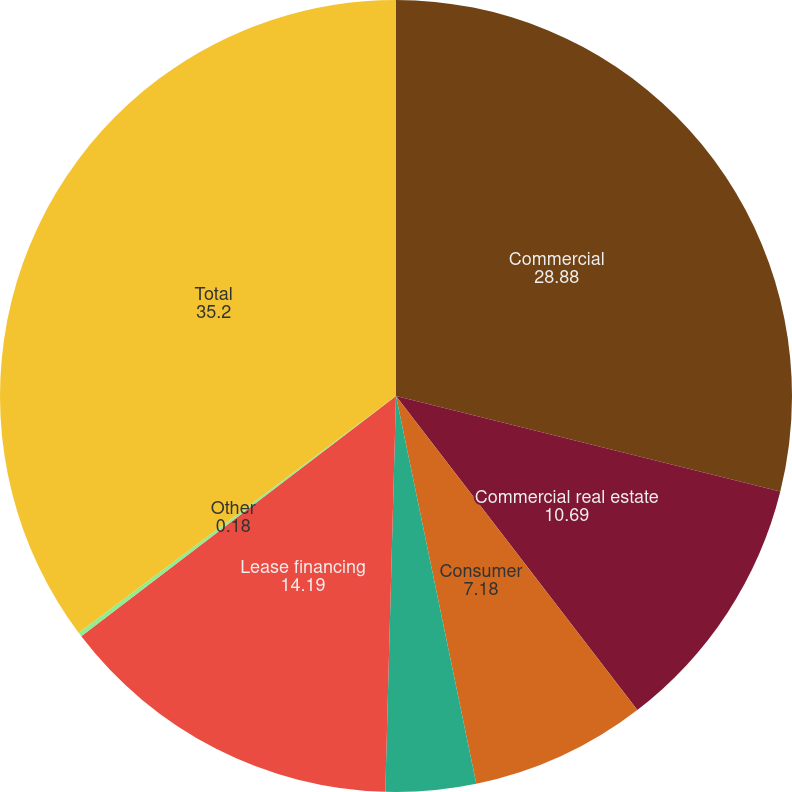Convert chart to OTSL. <chart><loc_0><loc_0><loc_500><loc_500><pie_chart><fcel>Commercial<fcel>Commercial real estate<fcel>Consumer<fcel>Residential mortgage<fcel>Lease financing<fcel>Other<fcel>Total<nl><fcel>28.88%<fcel>10.69%<fcel>7.18%<fcel>3.68%<fcel>14.19%<fcel>0.18%<fcel>35.2%<nl></chart> 